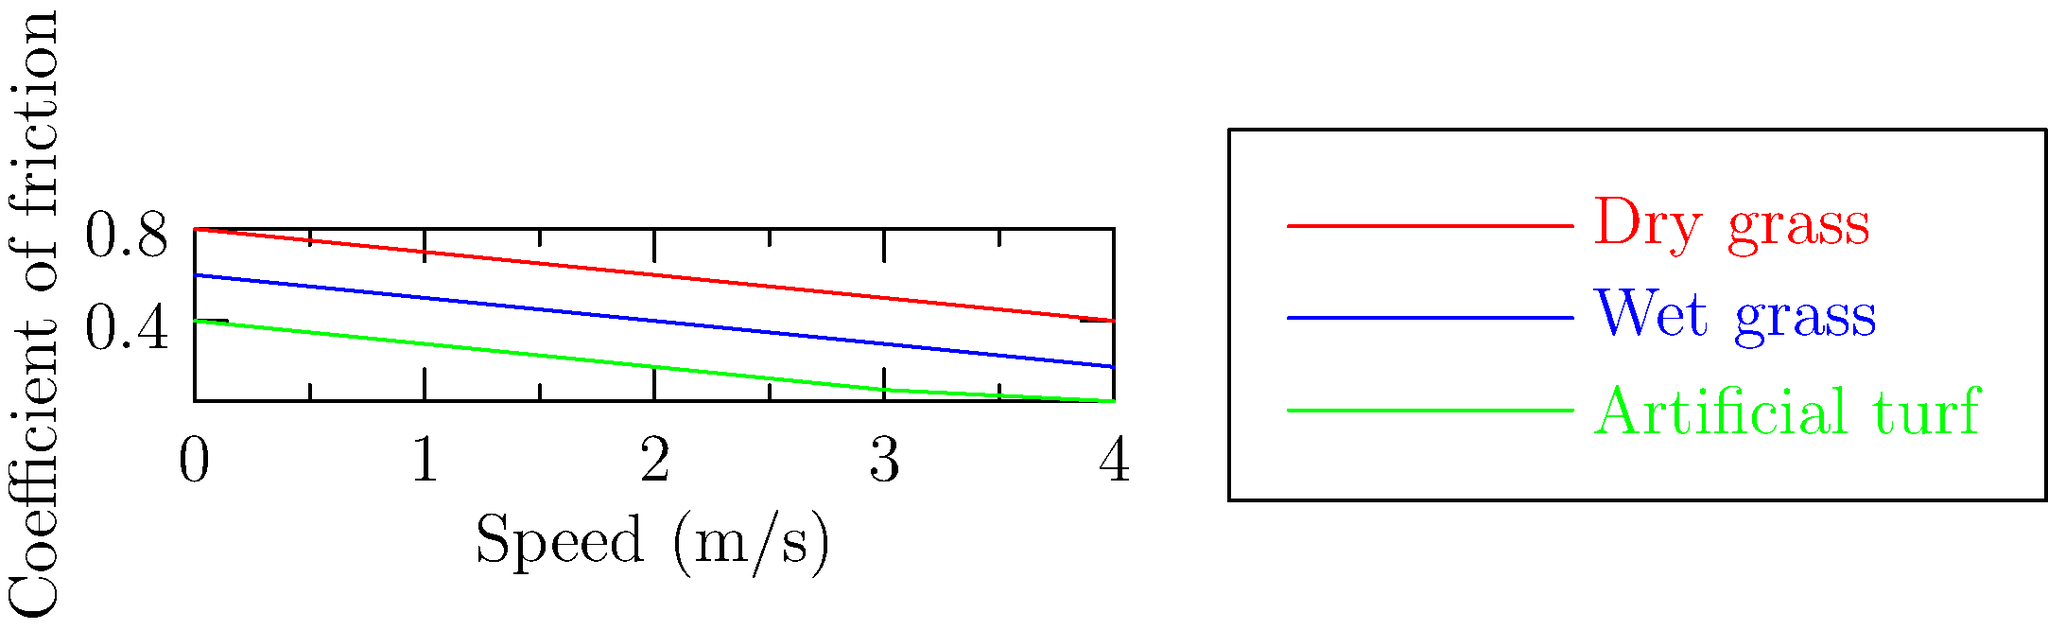In a crucial match between underdog FC Rostov and powerhouse Zenit St. Petersburg, a Rostov defender attempts a sliding tackle on a wet grass pitch. If the initial speed of the defender is 3 m/s, what would be the approximate stopping distance, assuming the defender's mass is 75 kg and the average friction force during the slide is 150 N? To solve this problem, we'll use the work-energy theorem and the concept of friction. Let's break it down step-by-step:

1) The work-energy theorem states that the work done on an object equals its change in kinetic energy:
   $$W = \Delta KE$$

2) Work done by friction is force times distance:
   $$W = F_f \cdot d$$
   where $F_f$ is the friction force and $d$ is the stopping distance.

3) The change in kinetic energy is the final kinetic energy minus the initial kinetic energy:
   $$\Delta KE = KE_f - KE_i = 0 - \frac{1}{2}mv_i^2$$
   where $m$ is the mass and $v_i$ is the initial velocity.

4) Equating these:
   $$F_f \cdot d = -\frac{1}{2}mv_i^2$$

5) Solving for $d$:
   $$d = \frac{mv_i^2}{2F_f}$$

6) Plugging in the values:
   $$d = \frac{75 \text{ kg} \cdot (3 \text{ m/s})^2}{2 \cdot 150 \text{ N}}$$

7) Calculating:
   $$d = \frac{675}{300} = 2.25 \text{ m}$$

Therefore, the approximate stopping distance would be 2.25 meters.

Note: The graph shows that wet grass has a lower coefficient of friction than dry grass, which is consistent with the slippery conditions described in the question.
Answer: 2.25 m 